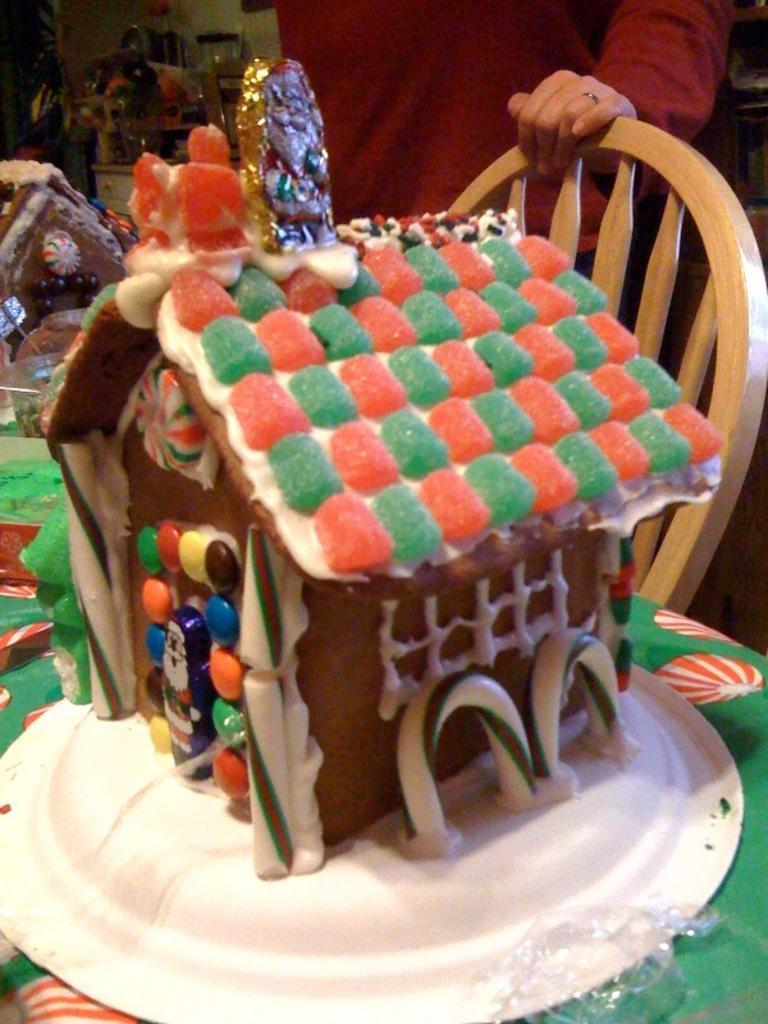How would you summarize this image in a sentence or two? In this image there is a table, on that table there is a plate, in that plate there is a cake, beside the table there is a chair, behind the chair there is a person standing. 